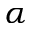<formula> <loc_0><loc_0><loc_500><loc_500>\alpha</formula> 